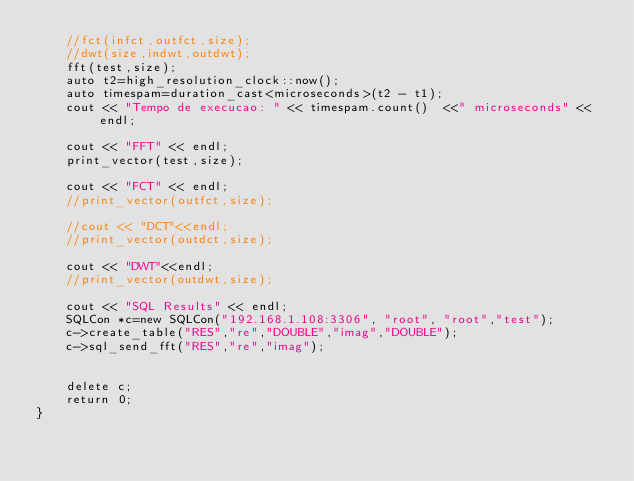<code> <loc_0><loc_0><loc_500><loc_500><_C++_>	//fct(infct,outfct,size);
	//dwt(size,indwt,outdwt);
	fft(test,size);
	auto t2=high_resolution_clock::now();
	auto timespam=duration_cast<microseconds>(t2 - t1);
	cout << "Tempo de execucao: " << timespam.count()  <<" microseconds" << endl;

	cout << "FFT" << endl;
	print_vector(test,size);

	cout << "FCT" << endl;
	//print_vector(outfct,size);

	//cout << "DCT"<<endl;
	//print_vector(outdct,size);

	cout << "DWT"<<endl;
	//print_vector(outdwt,size);

	cout << "SQL Results" << endl;
	SQLCon *c=new SQLCon("192.168.1.108:3306", "root", "root","test");
	c->create_table("RES","re","DOUBLE","imag","DOUBLE");
	c->sql_send_fft("RES","re","imag");


	delete c;
	return 0;
}
</code> 